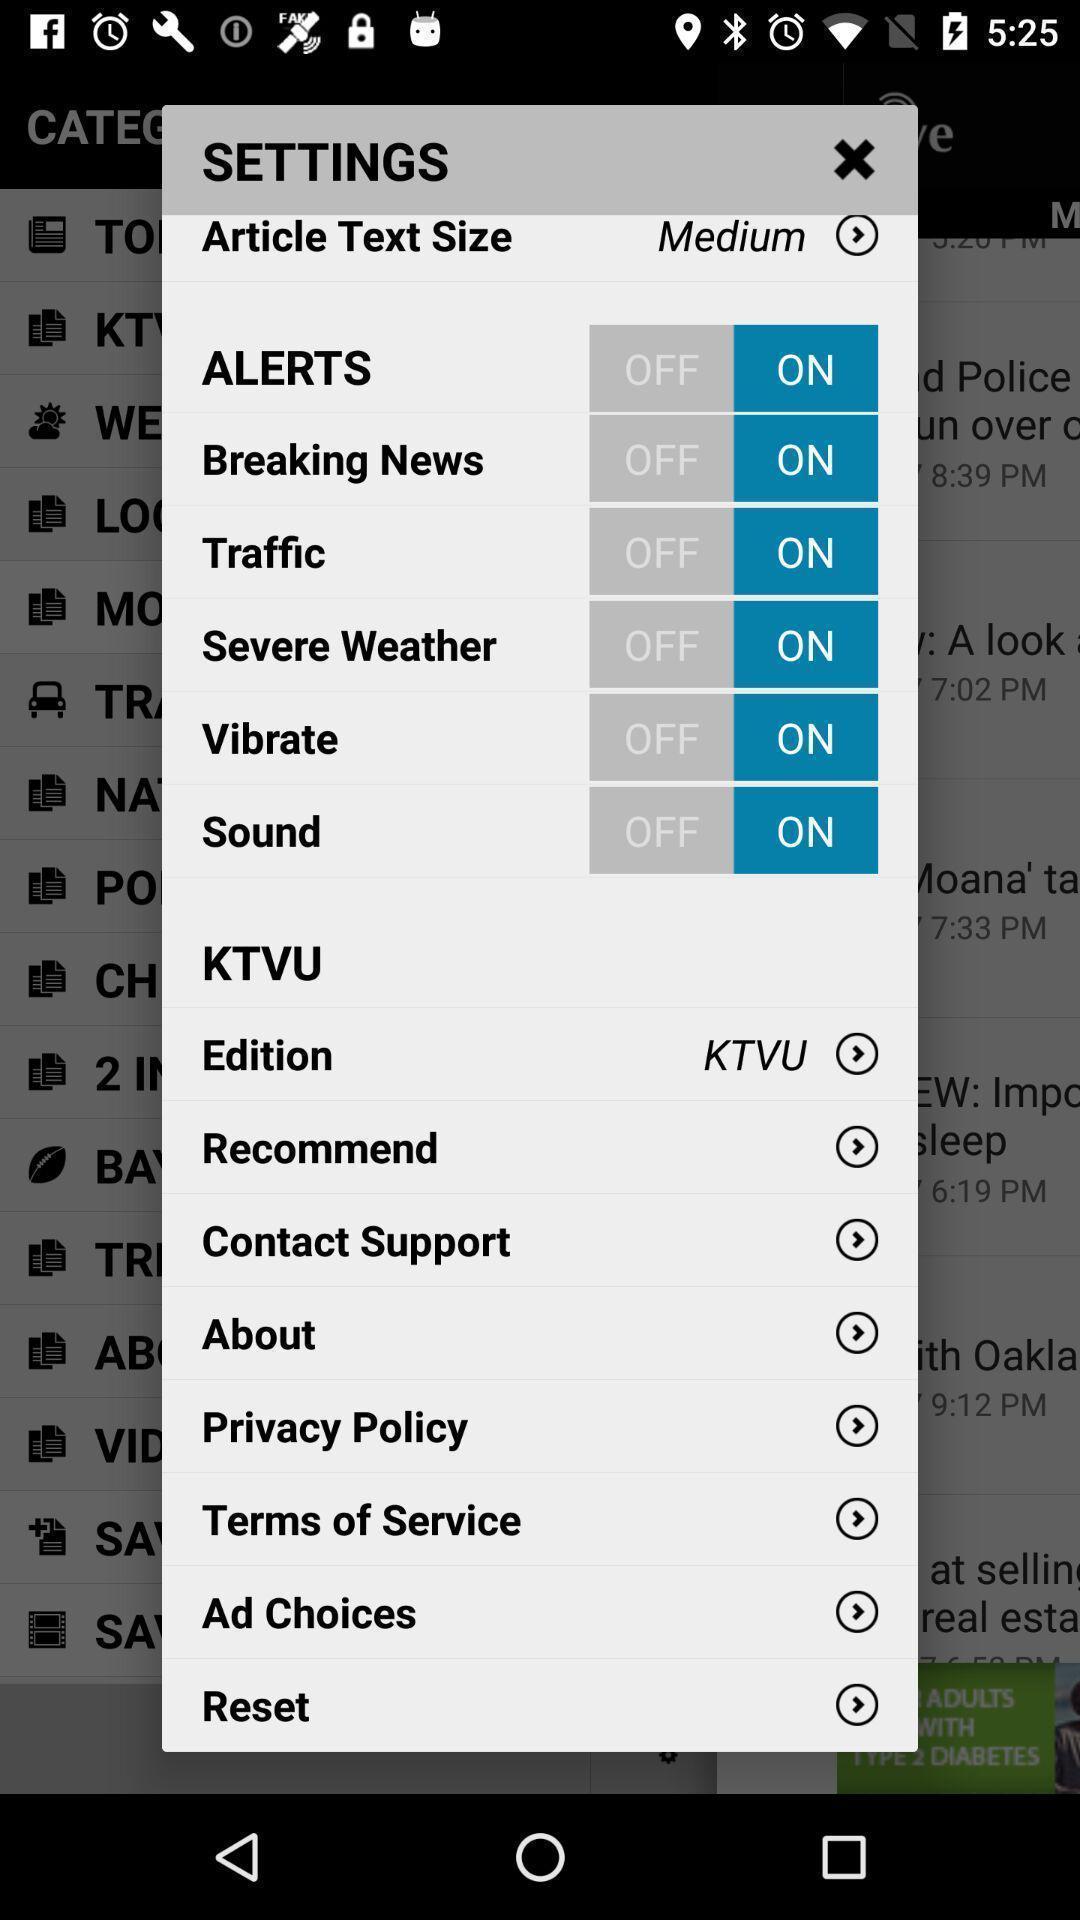Tell me what you see in this picture. Pop-up showing all the settings. 